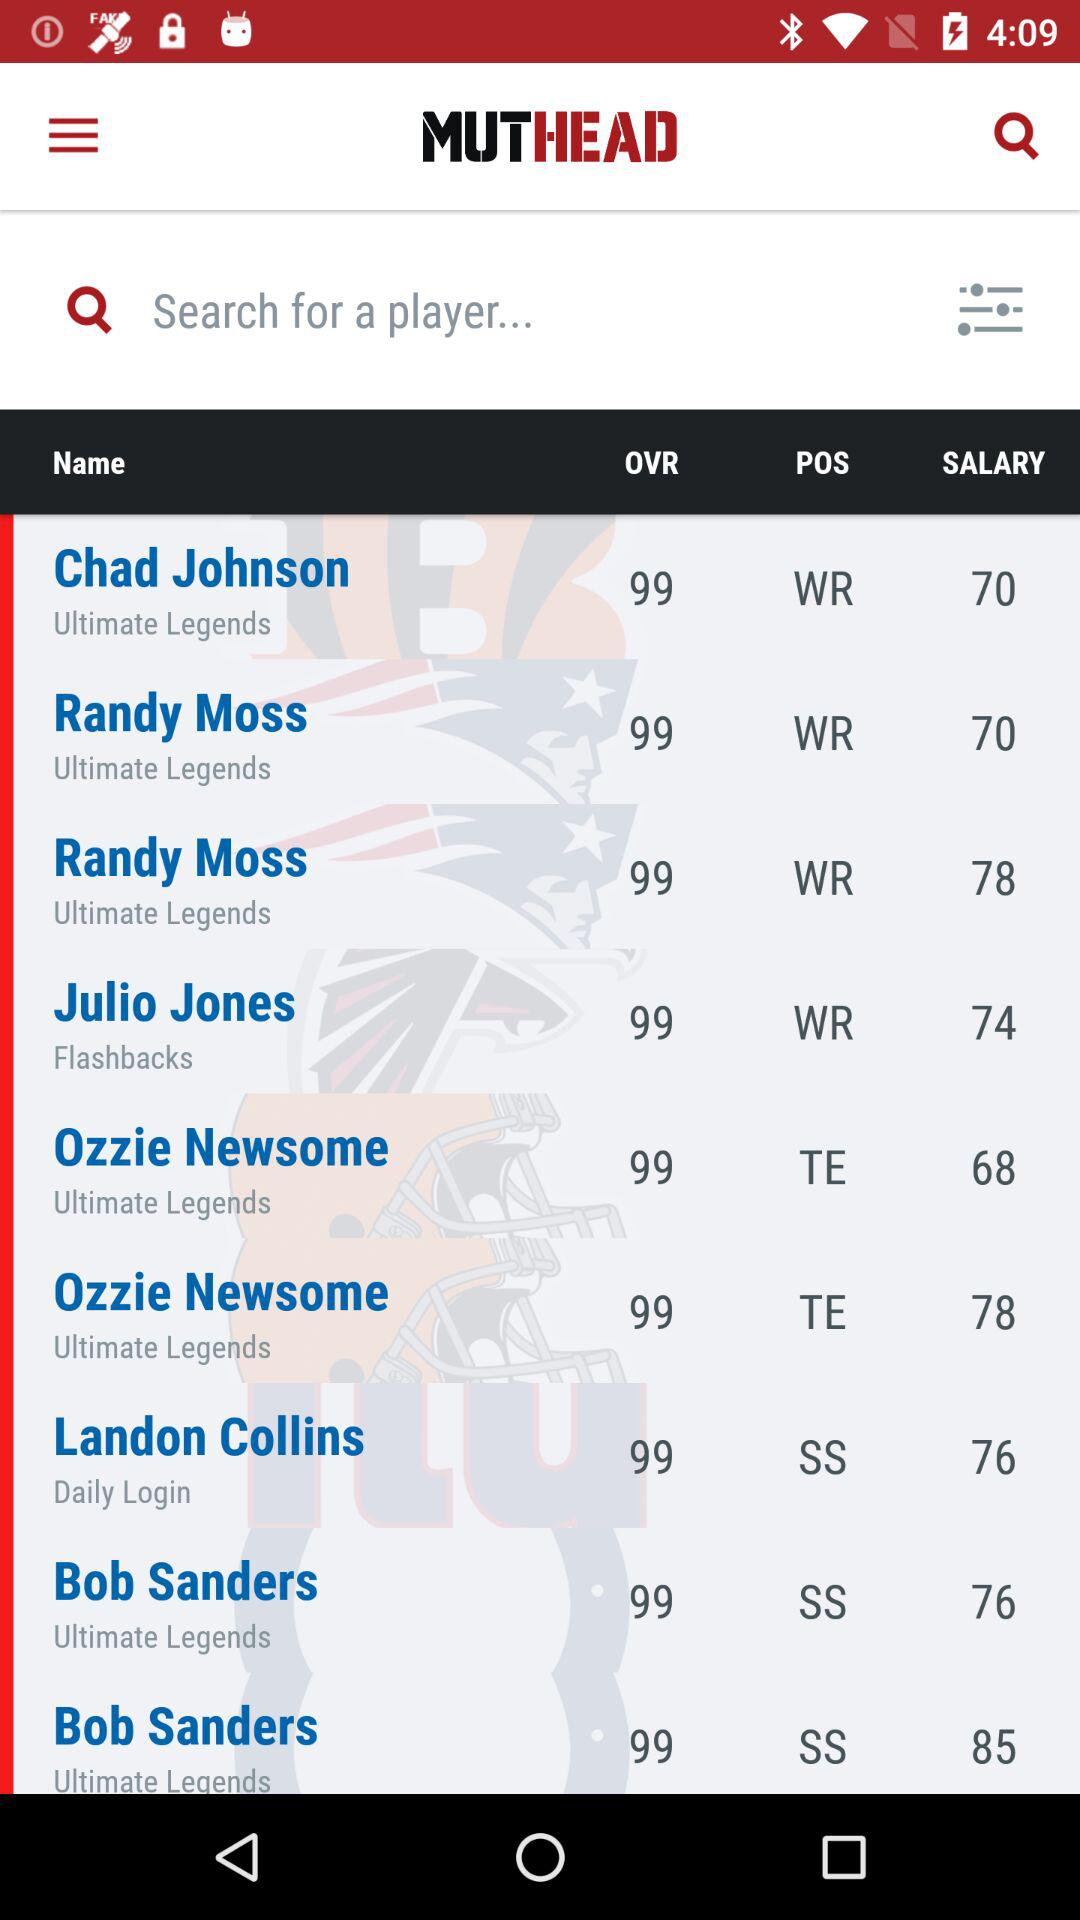What's the salary of Bob Sanders from "Ultimate Legends"? The salary of Bob Sanders from "Ultimate Legends" is 76 and 85. 